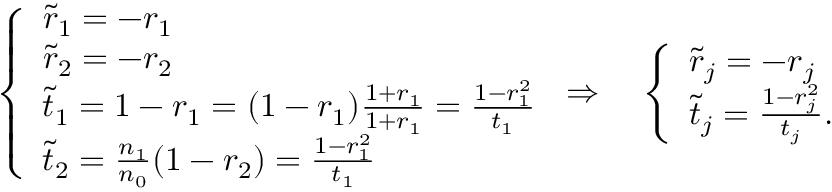Convert formula to latex. <formula><loc_0><loc_0><loc_500><loc_500>\left \{ \begin{array} { l l } { \tilde { r } _ { 1 } = - r _ { 1 } } \\ { \tilde { r } _ { 2 } = - r _ { 2 } } \\ { \tilde { t } _ { 1 } = 1 - r _ { 1 } = ( 1 - r _ { 1 } ) \frac { 1 + r _ { 1 } } { 1 + r _ { 1 } } = \frac { 1 - r _ { 1 } ^ { 2 } } { t _ { 1 } } } \\ { \tilde { t } _ { 2 } = \frac { n _ { 1 } } { n _ { 0 } } ( 1 - r _ { 2 } ) = \frac { 1 - r _ { 1 } ^ { 2 } } { t _ { 1 } } } \end{array} \Rightarrow \quad \left \{ \begin{array} { l l } { \tilde { r } _ { j } = - r _ { j } } \\ { \tilde { t } _ { j } = \frac { 1 - r _ { j } ^ { 2 } } { t _ { j } } . } \end{array}</formula> 